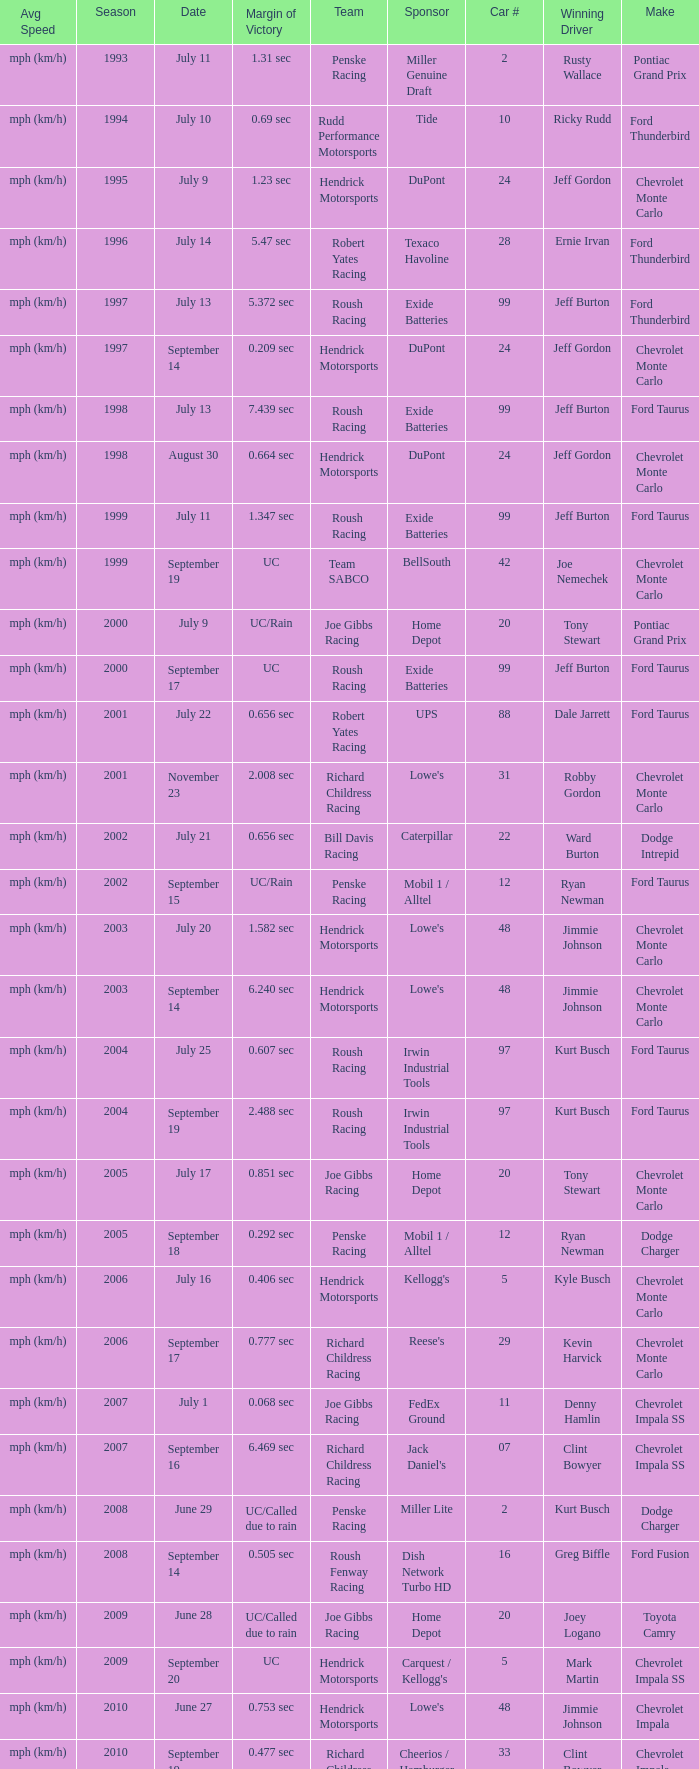What was the average speed of Tony Stewart's winning Chevrolet Impala? Mph (km/h). 